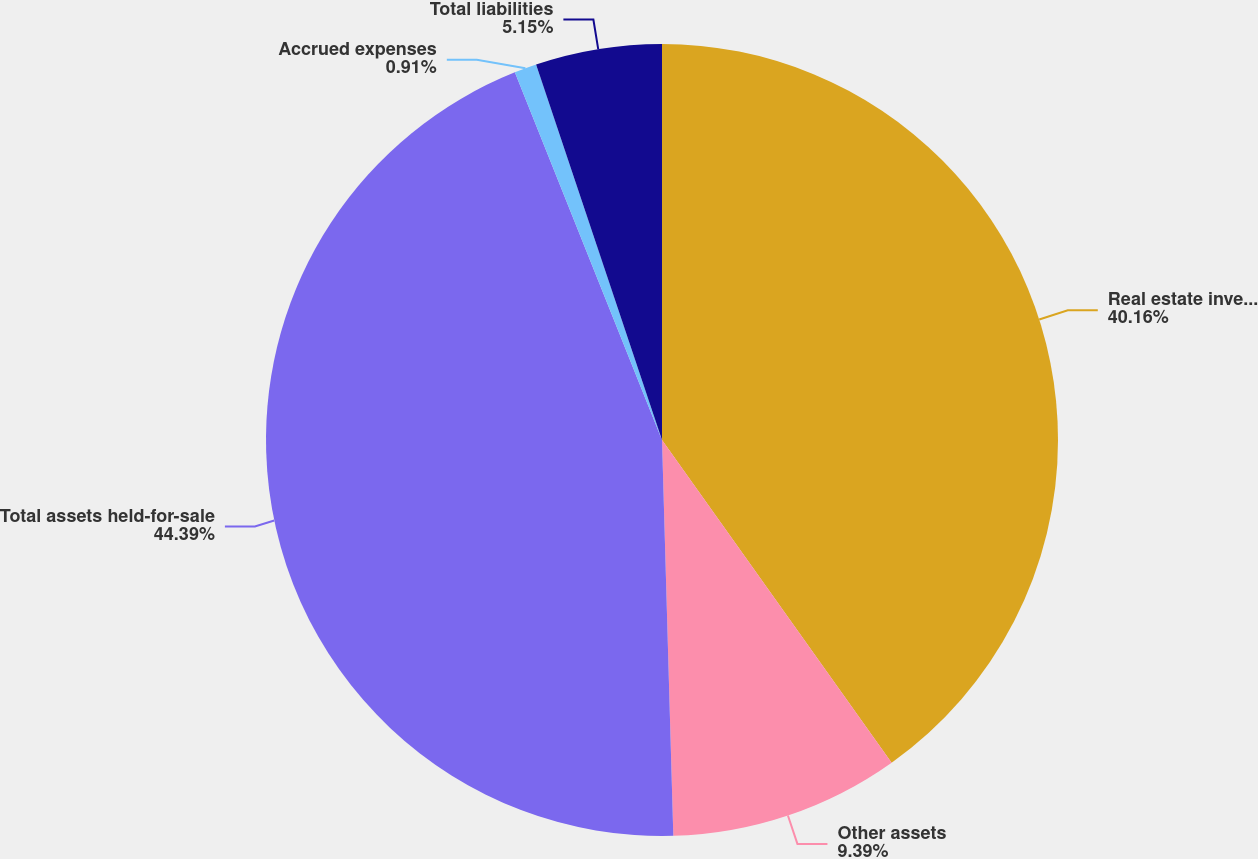Convert chart to OTSL. <chart><loc_0><loc_0><loc_500><loc_500><pie_chart><fcel>Real estate investments net<fcel>Other assets<fcel>Total assets held-for-sale<fcel>Accrued expenses<fcel>Total liabilities<nl><fcel>40.16%<fcel>9.39%<fcel>44.4%<fcel>0.91%<fcel>5.15%<nl></chart> 